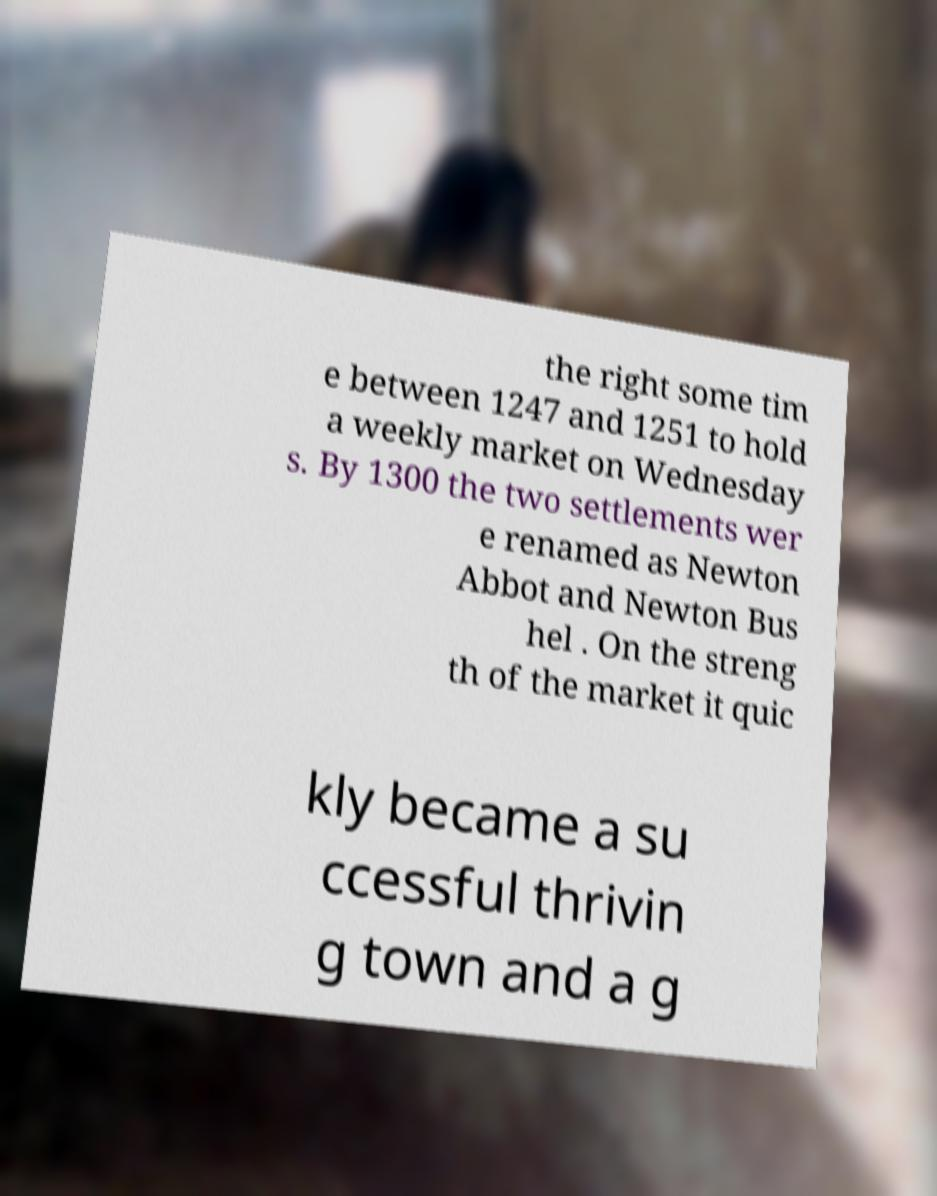What messages or text are displayed in this image? I need them in a readable, typed format. the right some tim e between 1247 and 1251 to hold a weekly market on Wednesday s. By 1300 the two settlements wer e renamed as Newton Abbot and Newton Bus hel . On the streng th of the market it quic kly became a su ccessful thrivin g town and a g 